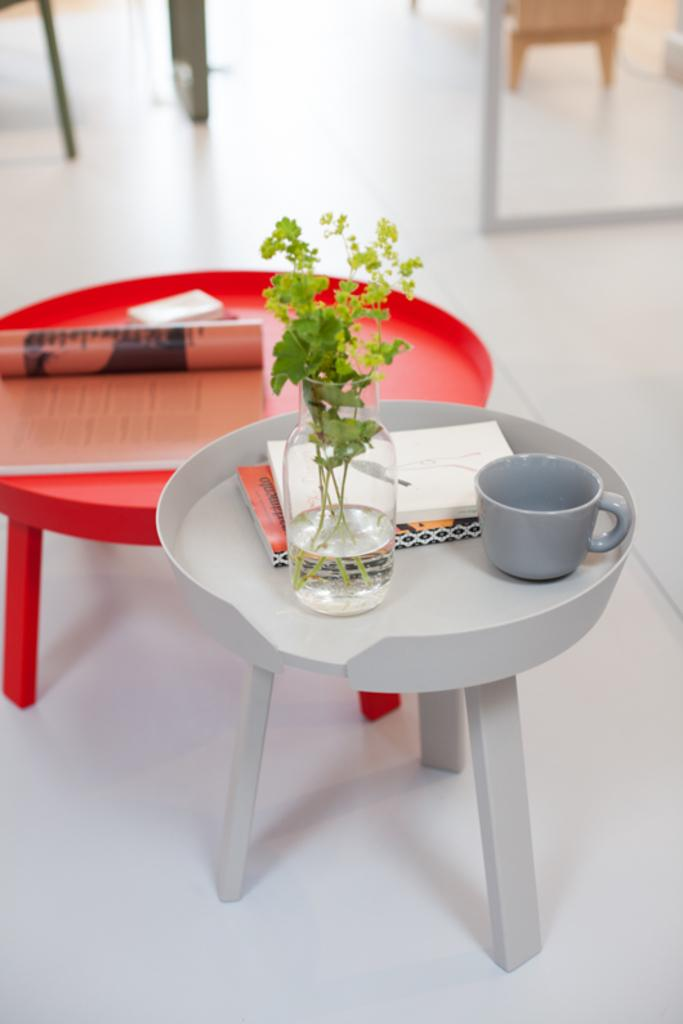What piece of furniture is in the image? There is a stool in the image. What is placed on the stool? A cup, books, and a jar with plants and water are placed on the stool. What is the color of the table in the background of the image? There is a red color table in the background of the image. What type of underwear is hanging on the stool in the image? There is no underwear present in the image. How many times does the person in the image sneeze? There is no person present in the image, so it is impossible to determine how many times they sneeze. 